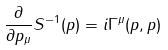<formula> <loc_0><loc_0><loc_500><loc_500>\frac { \partial } { \partial p _ { \mu } } S ^ { - 1 } ( p ) = i \Gamma ^ { \mu } ( p , p )</formula> 